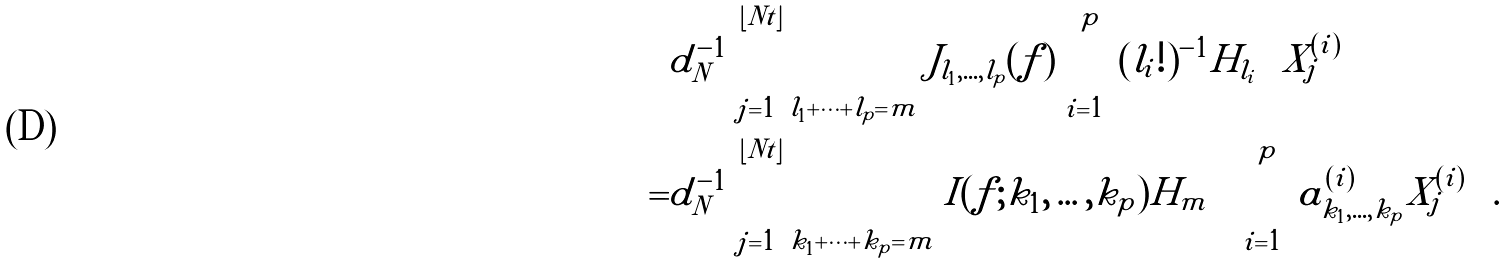<formula> <loc_0><loc_0><loc_500><loc_500>& d _ { N } ^ { - 1 } \sum _ { j = 1 } ^ { \lfloor N t \rfloor } \sum _ { l _ { 1 } + \dots + l _ { p } = m } J _ { l _ { 1 } , \dots , l _ { p } } ( f ) \prod _ { i = 1 } ^ { p } ( l _ { i } ! ) ^ { - 1 } H _ { l _ { i } } \left ( X _ { j } ^ { ( i ) } \right ) \\ = & d _ { N } ^ { - 1 } \sum _ { j = 1 } ^ { \lfloor N t \rfloor } \sum _ { k _ { 1 } + \dots + k _ { p } = m } I ( f ; k _ { 1 } , \dots , k _ { p } ) H _ { m } \left ( \sum _ { i = 1 } ^ { p } a _ { k _ { 1 } , \dots , k _ { p } } ^ { ( i ) } X _ { j } ^ { ( i ) } \right ) .</formula> 